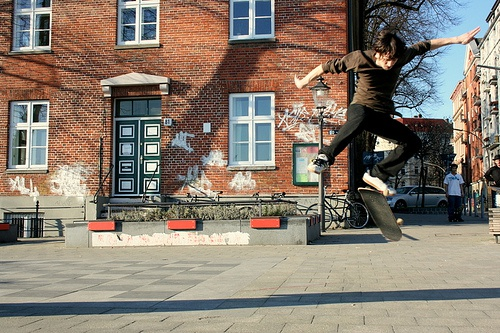Describe the objects in this image and their specific colors. I can see people in brown, black, maroon, and gray tones, skateboard in brown, gray, black, and darkgray tones, bicycle in brown, black, gray, darkgray, and beige tones, car in brown, black, blue, gray, and darkblue tones, and people in brown, black, and gray tones in this image. 